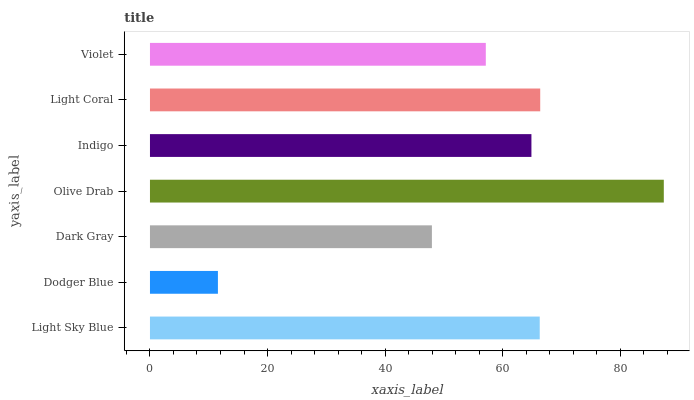Is Dodger Blue the minimum?
Answer yes or no. Yes. Is Olive Drab the maximum?
Answer yes or no. Yes. Is Dark Gray the minimum?
Answer yes or no. No. Is Dark Gray the maximum?
Answer yes or no. No. Is Dark Gray greater than Dodger Blue?
Answer yes or no. Yes. Is Dodger Blue less than Dark Gray?
Answer yes or no. Yes. Is Dodger Blue greater than Dark Gray?
Answer yes or no. No. Is Dark Gray less than Dodger Blue?
Answer yes or no. No. Is Indigo the high median?
Answer yes or no. Yes. Is Indigo the low median?
Answer yes or no. Yes. Is Light Coral the high median?
Answer yes or no. No. Is Light Coral the low median?
Answer yes or no. No. 